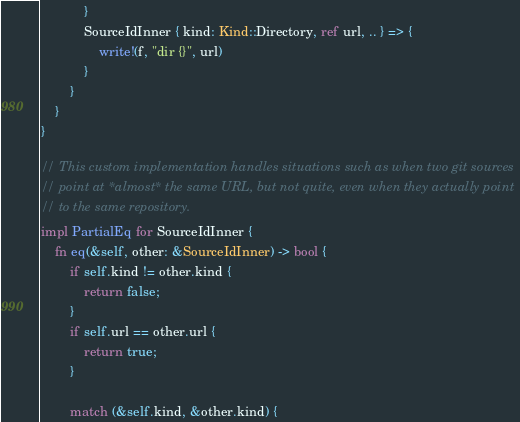Convert code to text. <code><loc_0><loc_0><loc_500><loc_500><_Rust_>            }
            SourceIdInner { kind: Kind::Directory, ref url, .. } => {
                write!(f, "dir {}", url)
            }
        }
    }
}

// This custom implementation handles situations such as when two git sources
// point at *almost* the same URL, but not quite, even when they actually point
// to the same repository.
impl PartialEq for SourceIdInner {
    fn eq(&self, other: &SourceIdInner) -> bool {
        if self.kind != other.kind {
            return false;
        }
        if self.url == other.url {
            return true;
        }

        match (&self.kind, &other.kind) {</code> 